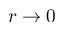<formula> <loc_0><loc_0><loc_500><loc_500>r \to 0</formula> 